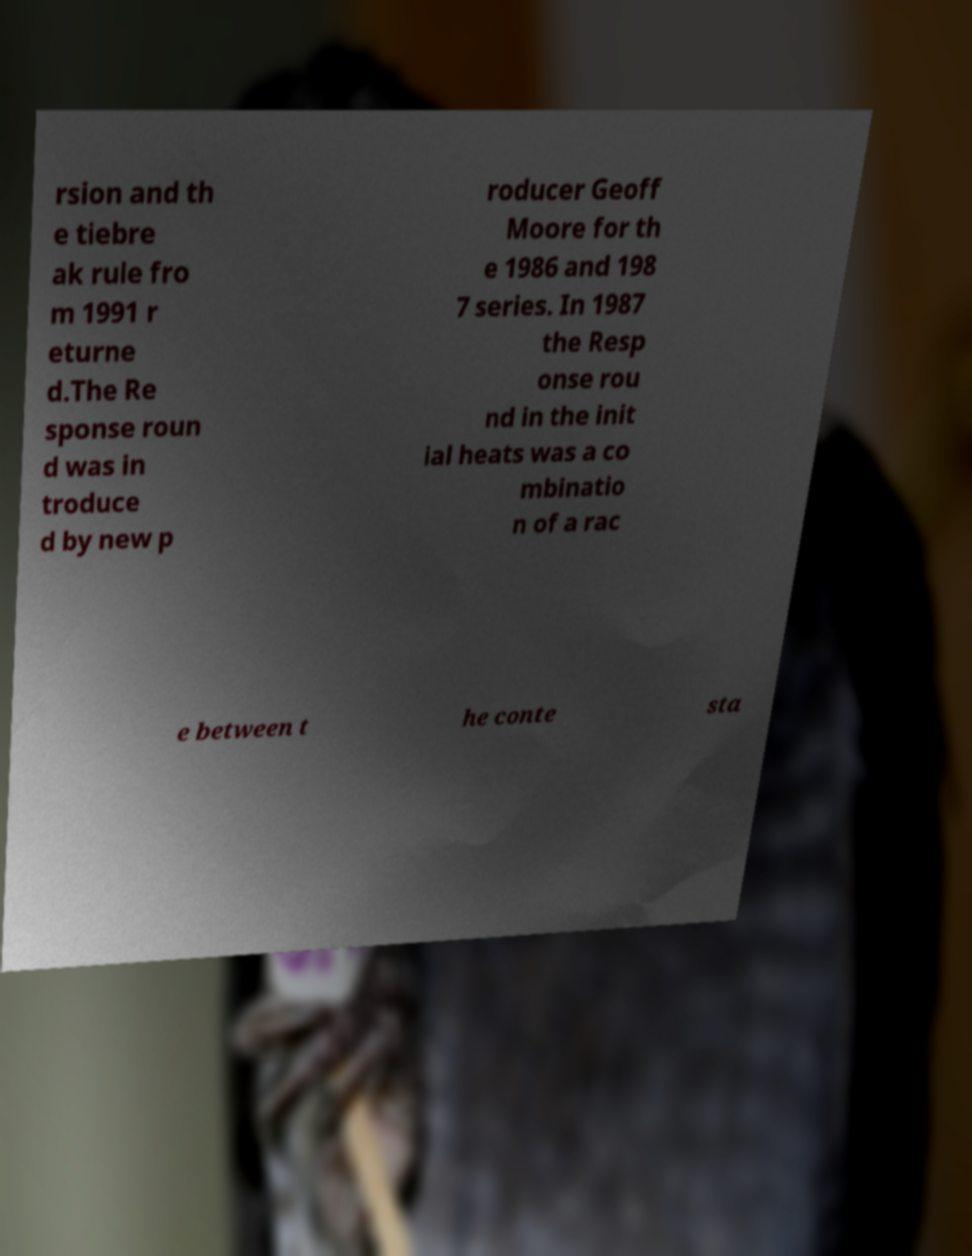I need the written content from this picture converted into text. Can you do that? rsion and th e tiebre ak rule fro m 1991 r eturne d.The Re sponse roun d was in troduce d by new p roducer Geoff Moore for th e 1986 and 198 7 series. In 1987 the Resp onse rou nd in the init ial heats was a co mbinatio n of a rac e between t he conte sta 